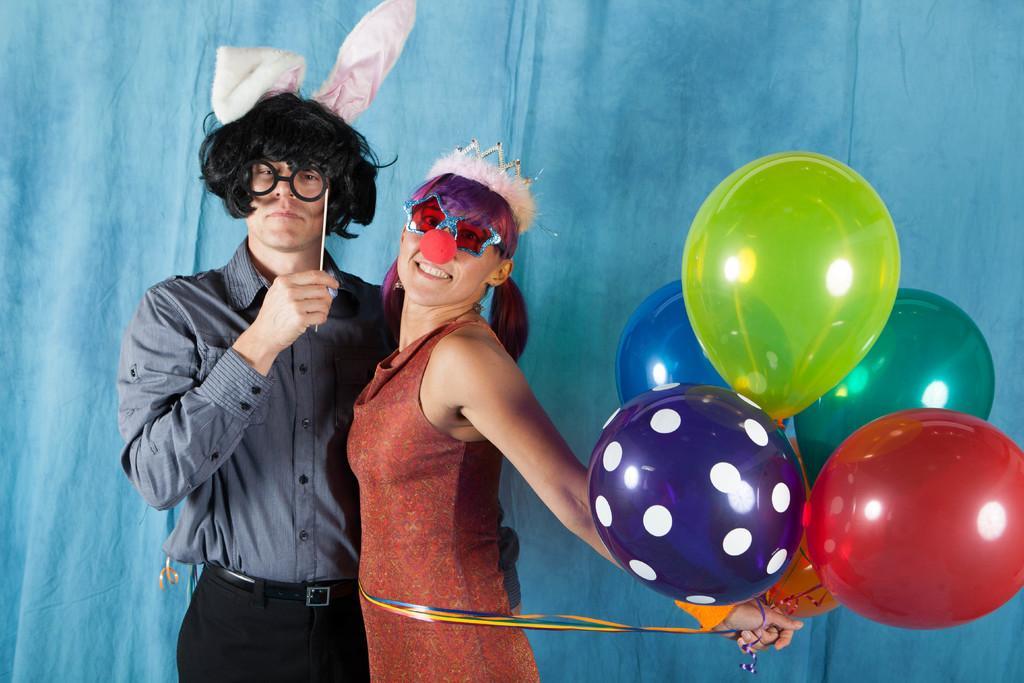Could you give a brief overview of what you see in this image? In this picture there are people standing and there is a woman holding ribbons with balloons and wore clown nose, crown and goggles. In the background of the image it is blue. 